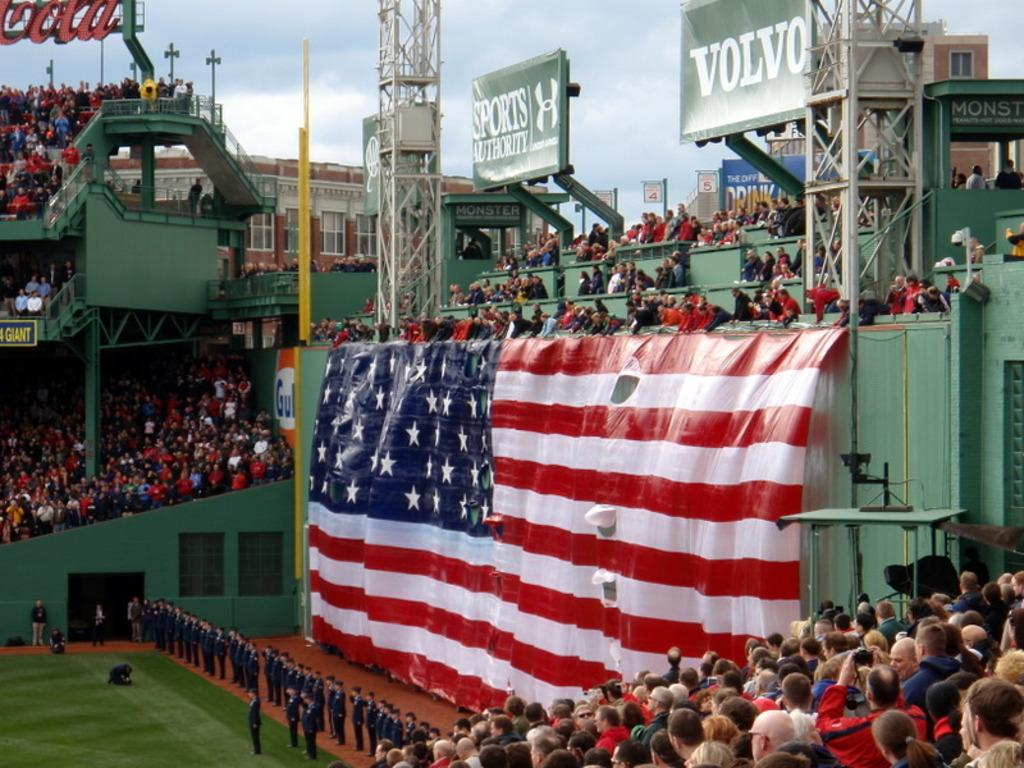<image>
Write a terse but informative summary of the picture. A sports game with an American flag and an advert for Volvo 